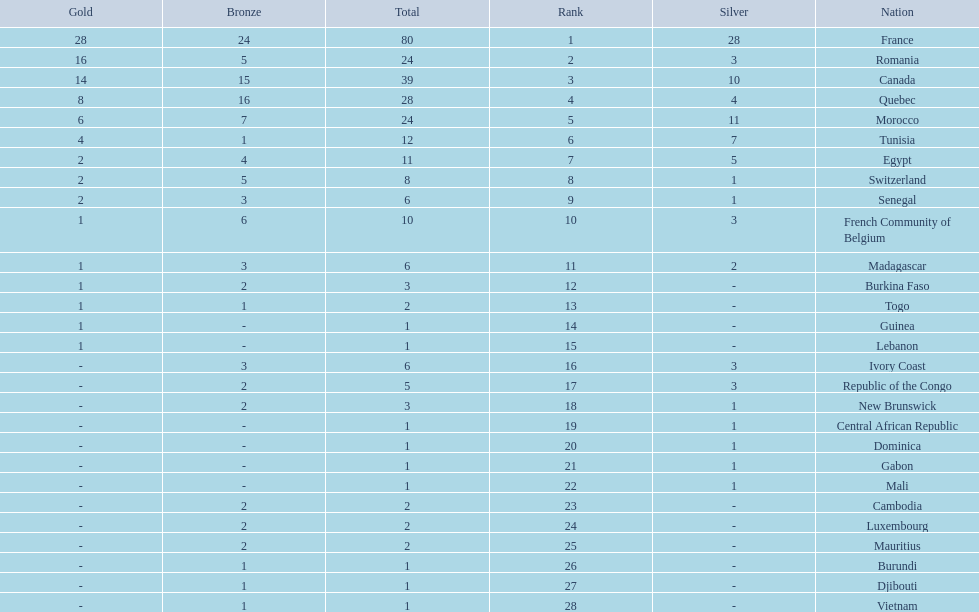Would you mind parsing the complete table? {'header': ['Gold', 'Bronze', 'Total', 'Rank', 'Silver', 'Nation'], 'rows': [['28', '24', '80', '1', '28', 'France'], ['16', '5', '24', '2', '3', 'Romania'], ['14', '15', '39', '3', '10', 'Canada'], ['8', '16', '28', '4', '4', 'Quebec'], ['6', '7', '24', '5', '11', 'Morocco'], ['4', '1', '12', '6', '7', 'Tunisia'], ['2', '4', '11', '7', '5', 'Egypt'], ['2', '5', '8', '8', '1', 'Switzerland'], ['2', '3', '6', '9', '1', 'Senegal'], ['1', '6', '10', '10', '3', 'French Community of Belgium'], ['1', '3', '6', '11', '2', 'Madagascar'], ['1', '2', '3', '12', '-', 'Burkina Faso'], ['1', '1', '2', '13', '-', 'Togo'], ['1', '-', '1', '14', '-', 'Guinea'], ['1', '-', '1', '15', '-', 'Lebanon'], ['-', '3', '6', '16', '3', 'Ivory Coast'], ['-', '2', '5', '17', '3', 'Republic of the Congo'], ['-', '2', '3', '18', '1', 'New Brunswick'], ['-', '-', '1', '19', '1', 'Central African Republic'], ['-', '-', '1', '20', '1', 'Dominica'], ['-', '-', '1', '21', '1', 'Gabon'], ['-', '-', '1', '22', '1', 'Mali'], ['-', '2', '2', '23', '-', 'Cambodia'], ['-', '2', '2', '24', '-', 'Luxembourg'], ['-', '2', '2', '25', '-', 'Mauritius'], ['-', '1', '1', '26', '-', 'Burundi'], ['-', '1', '1', '27', '-', 'Djibouti'], ['-', '1', '1', '28', '-', 'Vietnam']]} How many nations won at least 10 medals? 8. 